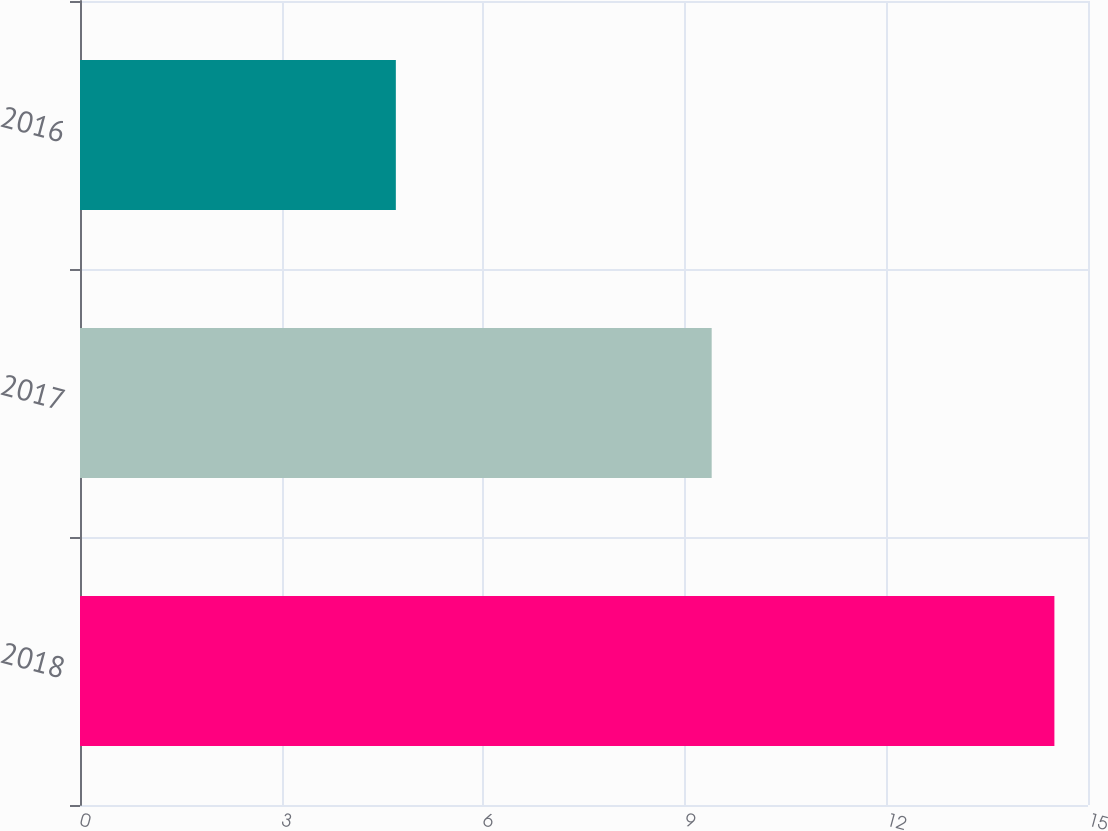Convert chart. <chart><loc_0><loc_0><loc_500><loc_500><bar_chart><fcel>2018<fcel>2017<fcel>2016<nl><fcel>14.5<fcel>9.4<fcel>4.7<nl></chart> 